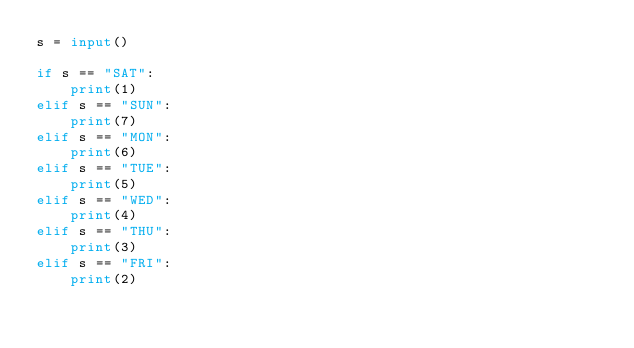<code> <loc_0><loc_0><loc_500><loc_500><_Python_>s = input()

if s == "SAT":
    print(1)
elif s == "SUN":
    print(7)
elif s == "MON":
    print(6)
elif s == "TUE":
    print(5)
elif s == "WED":
    print(4)
elif s == "THU":
    print(3)
elif s == "FRI":
    print(2)

</code> 